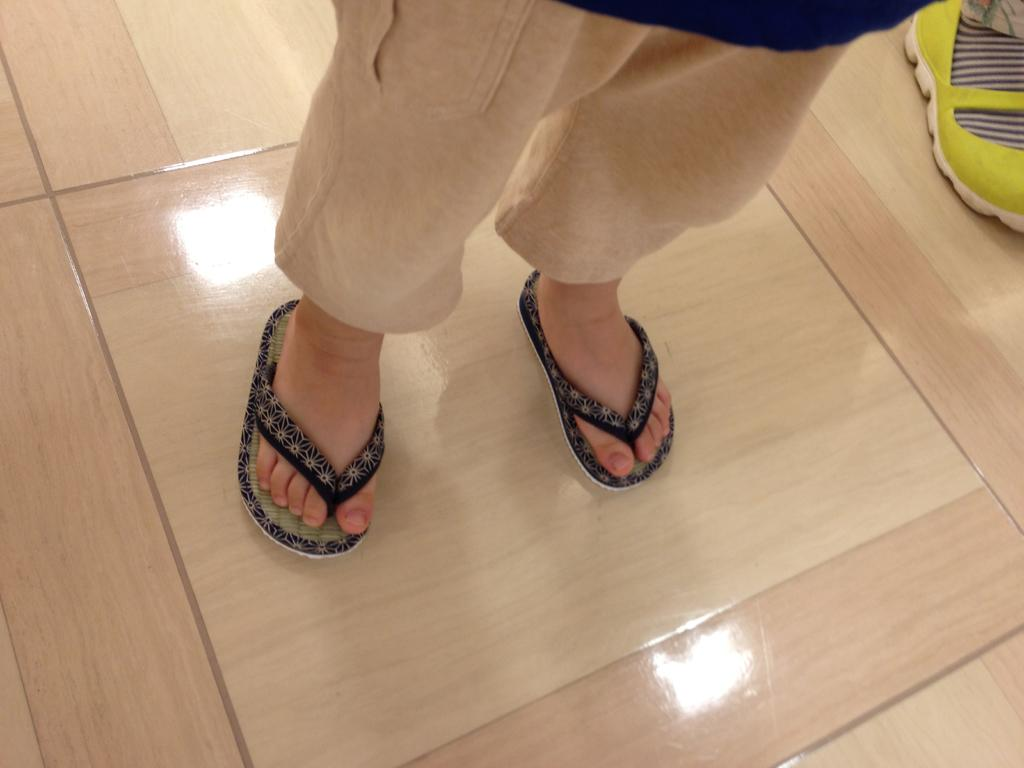What is the primary subject in the image? There is a person standing in the image. Where is the person standing? The person is standing on the floor. Can you describe any other objects in the image? There is a shoe in the image. What type of sea creature can be seen swimming near the person in the image? There is no sea creature present in the image; it features a person standing on the floor with a shoe nearby. 